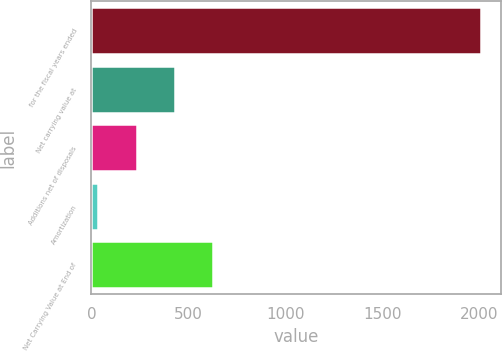Convert chart to OTSL. <chart><loc_0><loc_0><loc_500><loc_500><bar_chart><fcel>for the fiscal years ended<fcel>Net carrying value at<fcel>Additions net of disposals<fcel>Amortization<fcel>Net Carrying Value at End of<nl><fcel>2011<fcel>431.32<fcel>233.86<fcel>36.4<fcel>628.78<nl></chart> 